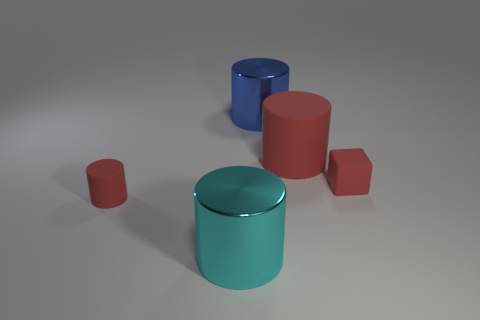What material is the red cube?
Offer a terse response. Rubber. There is a cyan object; what number of red objects are on the left side of it?
Make the answer very short. 1. Do the tiny matte cube and the tiny matte cylinder have the same color?
Ensure brevity in your answer.  Yes. What number of other cubes have the same color as the small rubber block?
Make the answer very short. 0. Are there more cyan metal things than small blue objects?
Offer a terse response. Yes. What size is the cylinder that is both in front of the big red rubber cylinder and behind the large cyan shiny cylinder?
Your answer should be compact. Small. Is the material of the red cylinder in front of the tiny rubber block the same as the large blue object that is to the left of the big rubber cylinder?
Offer a very short reply. No. What is the shape of the rubber thing that is the same size as the cyan cylinder?
Ensure brevity in your answer.  Cylinder. Are there fewer cylinders than small rubber cylinders?
Your response must be concise. No. There is a red rubber cylinder behind the tiny cylinder; is there a large red cylinder left of it?
Give a very brief answer. No. 